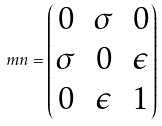<formula> <loc_0><loc_0><loc_500><loc_500>\ m n = \begin{pmatrix} 0 & \sigma & 0 \\ \sigma & 0 & \epsilon \\ 0 & \epsilon & 1 \end{pmatrix}</formula> 